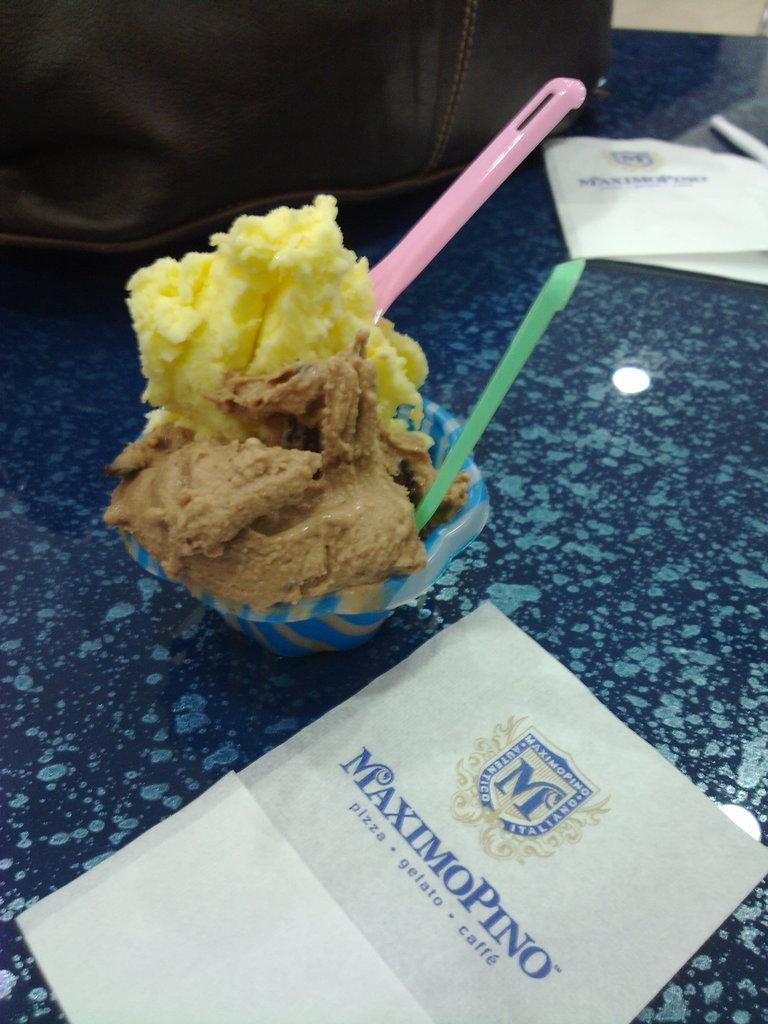Please provide a concise description of this image. This image consists of a cup in which there is ice-cream along with two spoons. At the bottom, there is a card. In the background, there is bag, All are kept on a table. 